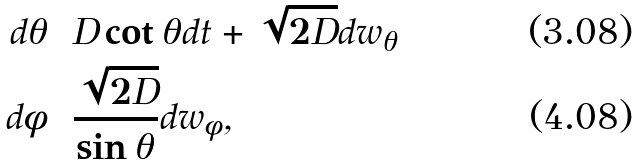Convert formula to latex. <formula><loc_0><loc_0><loc_500><loc_500>d \theta & = D \cot \theta d t + \sqrt { 2 D } d w _ { \theta } \\ d \phi & = \frac { \sqrt { 2 D } } { \sin \theta } d w _ { \phi } ,</formula> 